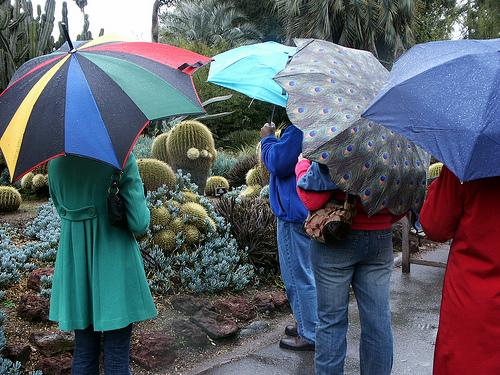Provide a concise description of the primary subject and their action in the image. A woman with a teal coat and striped umbrella is among others holding umbrellas in the rain, with some wearing blue jeans. Highlight the main objects in the image and any noticeable activity. Several people are standing in the rain with umbrellas, with some wearing blue jeans and one holding a peacock patterned umbrella. Describe the main activity taking place in the image and the main subject involved in it. People holding umbrellas, including a woman with a striped umbrella and teal coat, gather in the rain near a garden. Describe the center of attention in the image and what they are part of. The focus is a woman with a teal coat and striped umbrella, in a group of people holding umbrellas in the rain. Briefly mention the main focal point of the image and what is happening. The central focus is a woman in a teal coat with a striped umbrella, standing with others in the rain. State the main point of interest in the image and what is taking place. A woman in a teal coat holds a striped umbrella, standing with a group of people holding umbrellas in the rain. Identify the primary subject and their action, along with other notable elements in the image. A woman in a teal coat with a striped umbrella stands in the rain among others, some have unique umbrellas and wear blue jeans. Mention the primary focus of the image and their action. A woman holding a striped umbrella wears a teal coat, standing in the rain with others holding umbrellas too. Give a short description of the primary subject in the image and any noticeable event occurring. The main subject is a woman in a teal coat holding a striped umbrella, surrounded by others with umbrellas in the rain. Briefly describe the scene in the image, focusing on the main subject. A group of people with umbrellas are standing in the rain, including a woman with a striped umbrella and teal coat. 